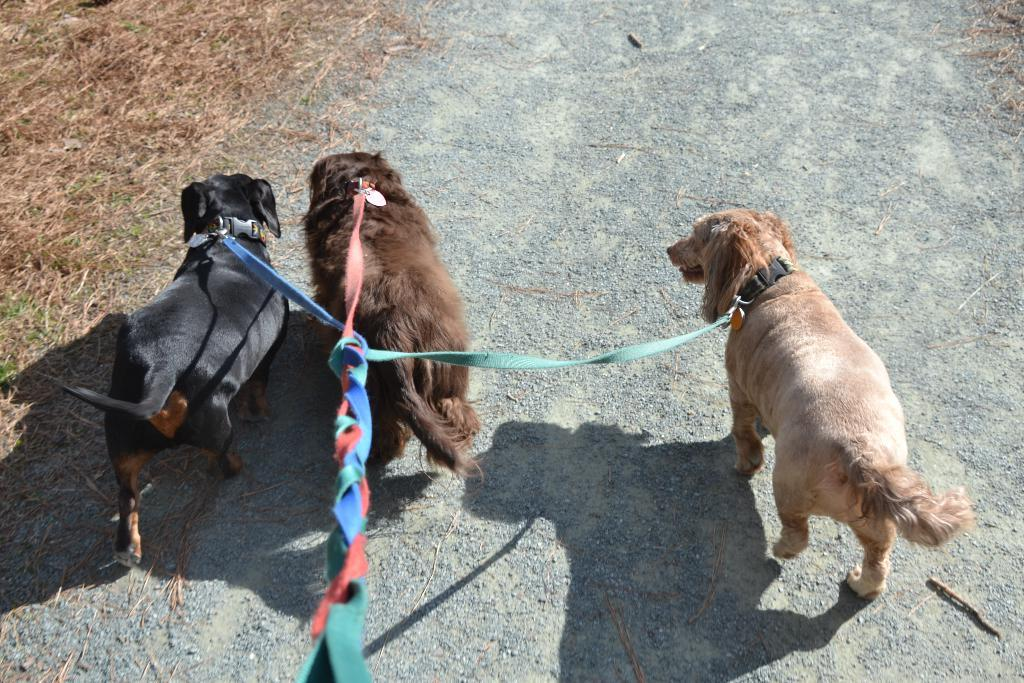How many dogs are in the image? There are three dogs in the image. What is the dogs' connection to each other in the image? The dogs are tied to a rope. What are the dogs doing in the image? The dogs are walking on a path. What type of vegetation is present on the left side of the path? Dry grass is present on the left side of the path. What type of desk can be seen in the image? There is no desk present in the image; it features three dogs walking on a path. 